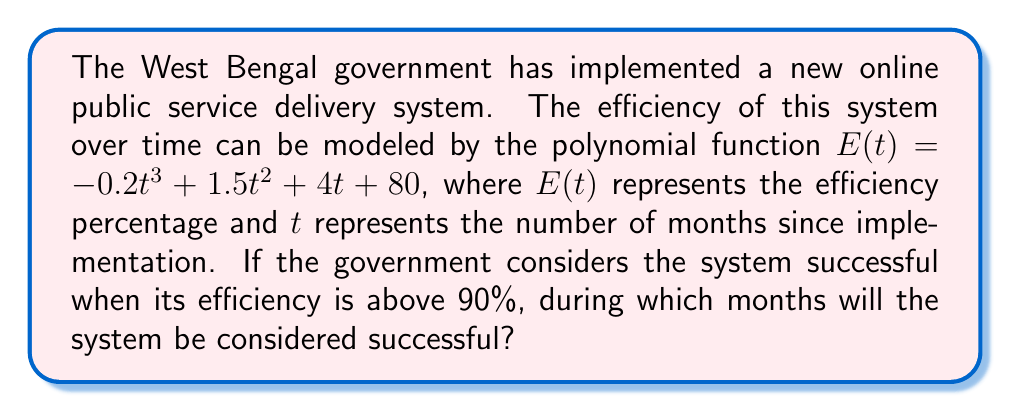Provide a solution to this math problem. To solve this problem, we need to follow these steps:

1) We need to find when $E(t) > 90$. This means solving the inequality:

   $-0.2t^3 + 1.5t^2 + 4t + 80 > 90$

2) Simplifying:

   $-0.2t^3 + 1.5t^2 + 4t - 10 > 0$

3) This is a cubic inequality. To solve it, we need to find the roots of the equation:

   $-0.2t^3 + 1.5t^2 + 4t - 10 = 0$

4) This is not easily factorable, so we can use the rational root theorem or a graphing calculator to find the roots. The roots are approximately:

   $t \approx -3.22, 1.37, 9.35$

5) Now, we can create a sign chart:

   $(-\infty, -3.22): \text{Negative}$
   $(-3.22, 1.37): \text{Positive}$
   $(1.37, 9.35): \text{Positive}$
   $(9.35, \infty): \text{Negative}$

6) The system is successful when the inequality is positive, which occurs in the intervals $(-3.22, 1.37)$ and $(1.37, 9.35)$.

7) Since $t$ represents months and can't be negative, we're only interested in the interval $(0, 9.35)$.

8) Rounding to the nearest month, the system will be successful from the 1st month to the 9th month after implementation.
Answer: The online public service delivery system will be considered successful from the 1st month to the 9th month after implementation. 